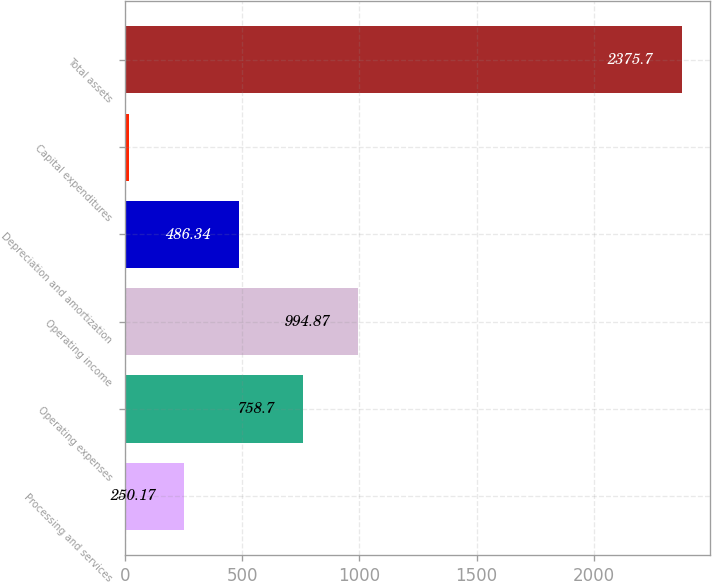<chart> <loc_0><loc_0><loc_500><loc_500><bar_chart><fcel>Processing and services<fcel>Operating expenses<fcel>Operating income<fcel>Depreciation and amortization<fcel>Capital expenditures<fcel>Total assets<nl><fcel>250.17<fcel>758.7<fcel>994.87<fcel>486.34<fcel>14<fcel>2375.7<nl></chart> 